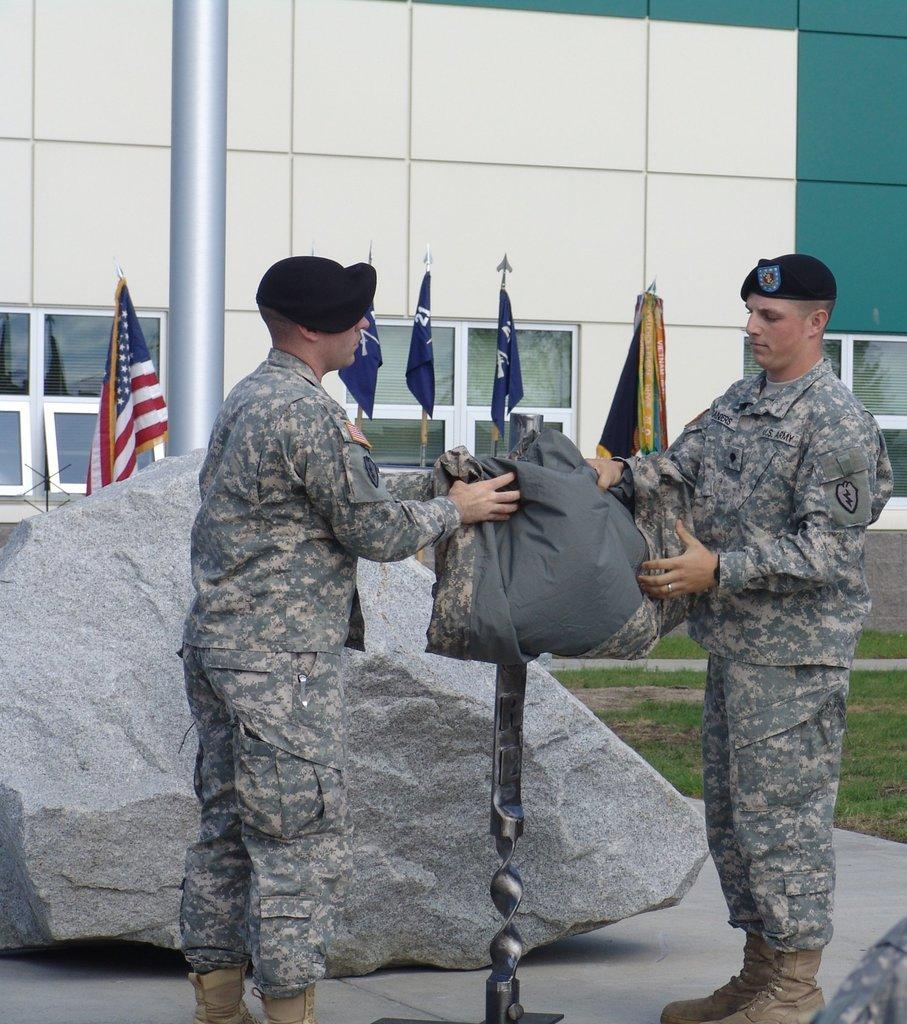How many military persons are in the image? There are two military persons in the image. What are the military persons holding in the image? The military persons are holding an object in the image. What is one other object visible in the image? There is a rock in the image. What type of structure can be seen in the image? There is a building in the image. What is another object visible in the image? There is a pole in the image. What can be seen flying in the image? There are flags in the image. What type of openings are present in the building? There are windows in the image. What type of outdoor area is visible in the image? There is a garden in the image. What type of instrument is the cat playing in the image? There is no cat or instrument present in the image. How many rabbits can be seen hopping in the garden in the image? There are no rabbits visible in the image; it only shows a garden. 